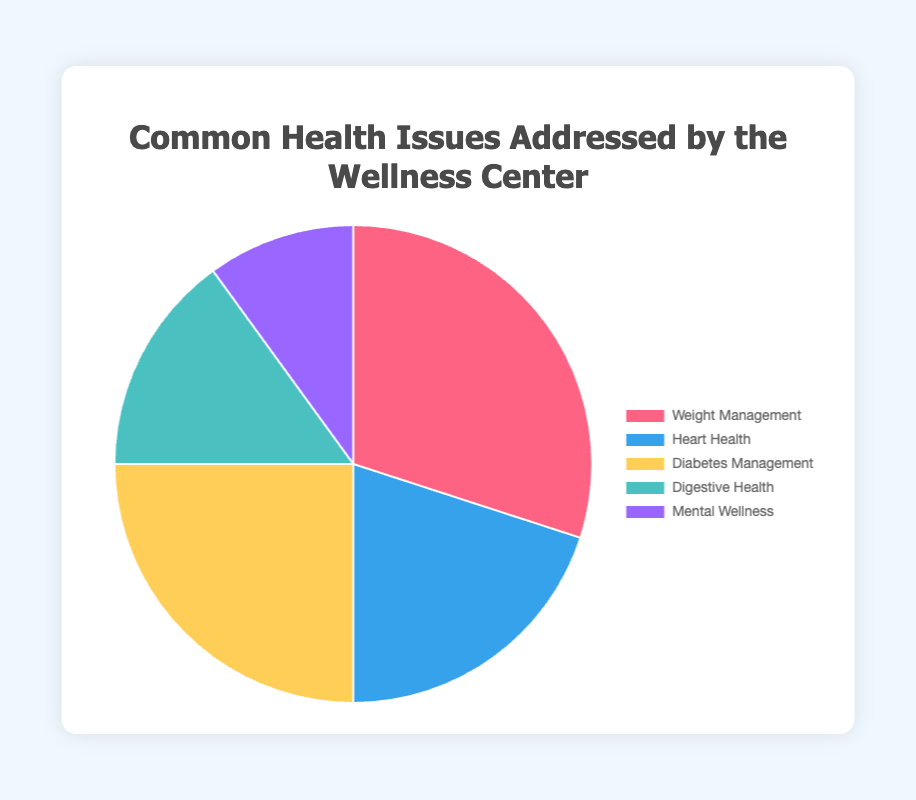What is the most common health issue addressed by the wellness center? Looking at the pie chart, the segment representing "Weight Management" is the largest, indicating it is the most common issue.
Answer: Weight Management What is the combined percentage of "Diabetes Management" and "Heart Health"? Add the percentages for "Diabetes Management" (25%) and "Heart Health" (20%) together: 25% + 20% = 45%.
Answer: 45% Which health issue has the smallest percentage of cases? The smallest segment in the pie chart corresponds to "Mental Wellness", which has the smallest percentage of cases.
Answer: Mental Wellness What is the difference in percentage between "Weight Management" and "Digestive Health"? Subtract the percentage for "Digestive Health" (15%) from "Weight Management" (30%): 30% - 15% = 15%.
Answer: 15% How much more common is "Diabetes Management" than "Digestive Health"? Subtract the percentage for "Digestive Health" (15%) from "Diabetes Management" (25%): 25% - 15% = 10%.
Answer: 10% If you combined "Mental Wellness" and "Digestive Health" into a single category, what percentage would that be? Add the percentages for "Mental Wellness" (10%) and "Digestive Health" (15%) together: 10% + 15% = 25%.
Answer: 25% Which two health issues combined make up half of the cases addressed by the wellness center? The two percentages that add up to 50% are "Weight Management" (30%) and "Diabetes Management" (25%), but since they add up to 55%, we'll consider "Weight Management" (30%) and "Heart Health" (20%), which sum to exactly 50%.
Answer: Weight Management and Heart Health What color represents "Heart Health" in the pie chart? By looking at the pie chart, the segment for "Heart Health" is colored blue.
Answer: blue What is the average percentage of the health issues addressed by the wellness center? Sum all the percentages: 30% + 20% + 25% + 15% + 10% = 100%. Then, divide by the number of issues (5): 100% / 5 = 20%.
Answer: 20% Is "Weight Management" addressed more often than the combination of "Digestive Health" and "Mental Wellness"? The percentage for "Weight Management" is 30%, while the combined percentage for "Digestive Health" (15%) and "Mental Wellness" (10%) is 25%. Therefore, "Weight Management" is more common.
Answer: Yes 